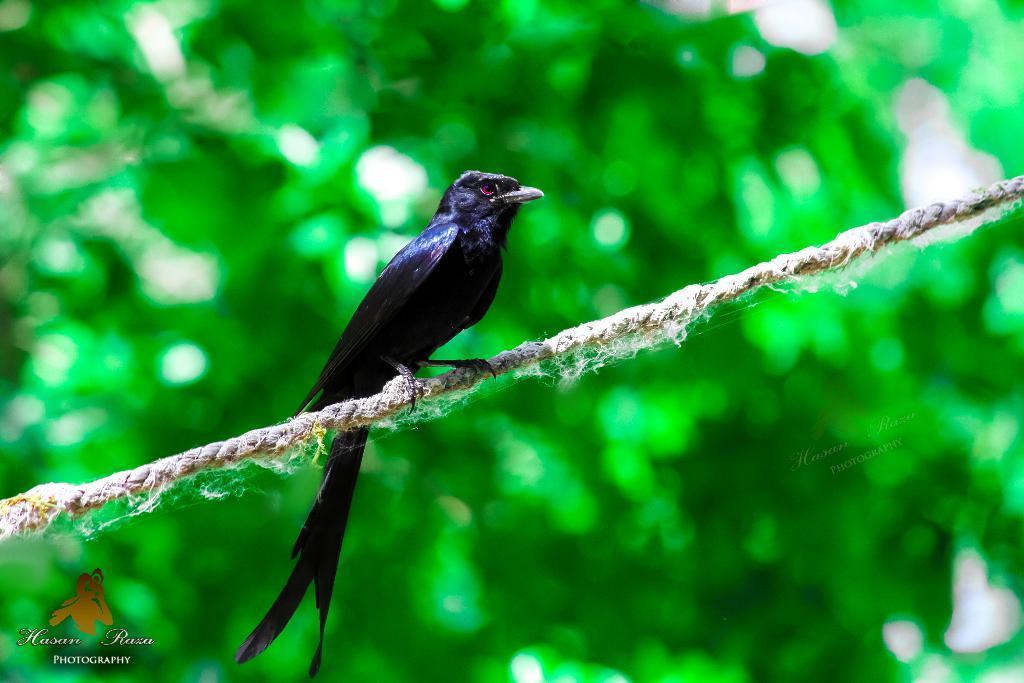Could you give a brief overview of what you see in this image? In the picture we can see a rope on it, we can see a bird which is black in color and behind it, we can see some plants which are not clearly visible. 